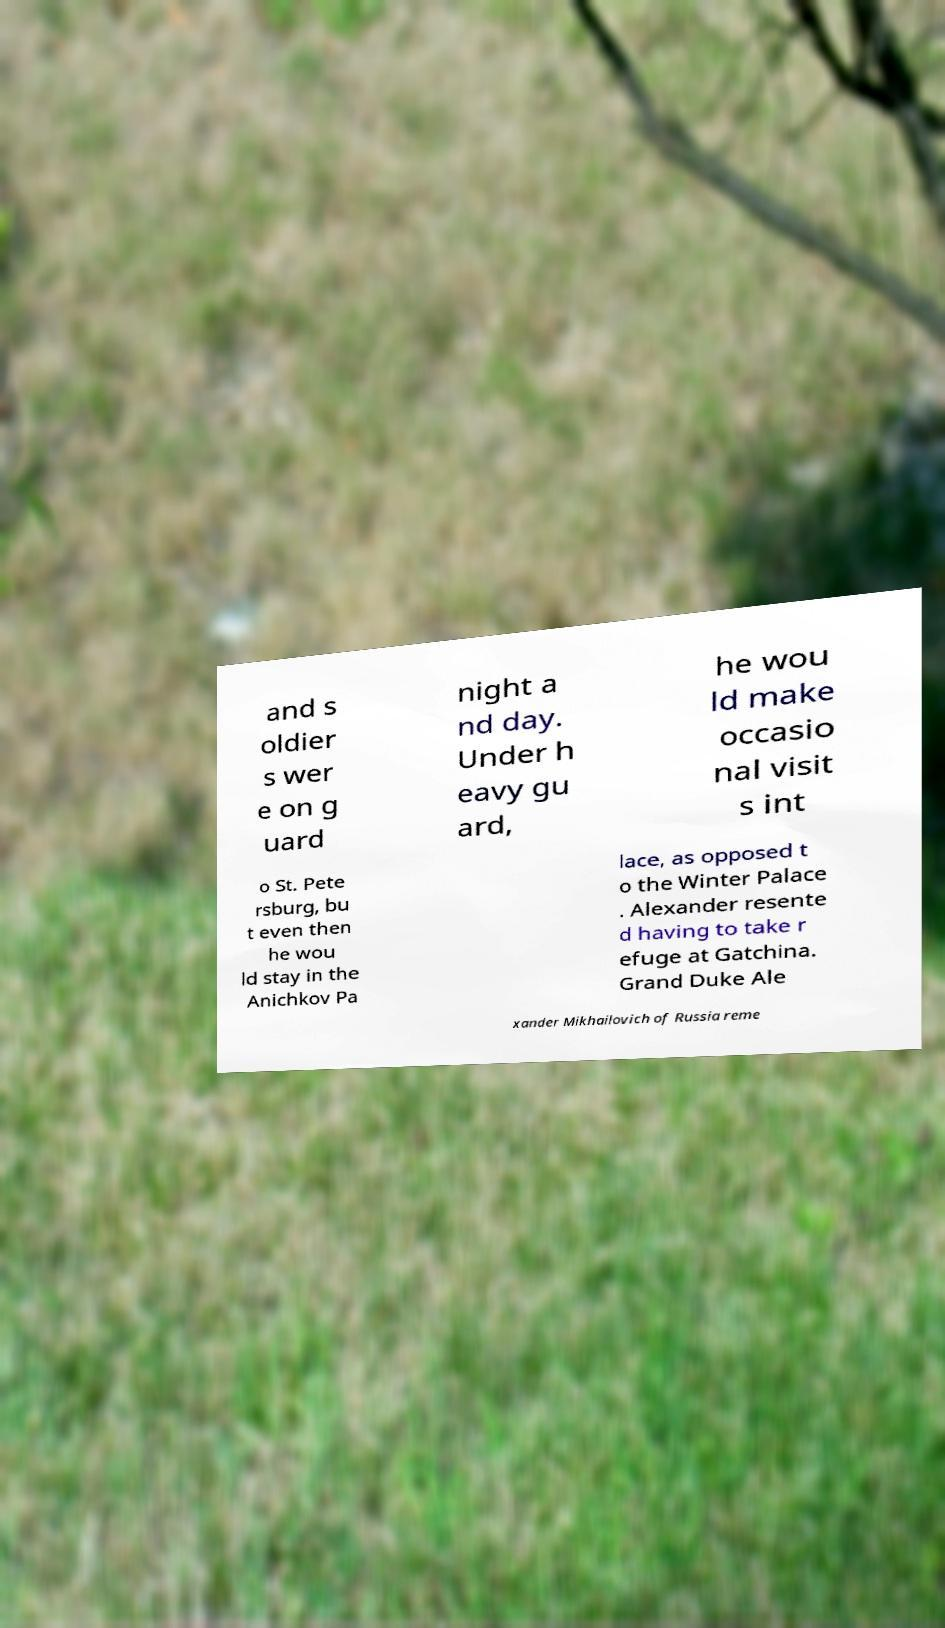Please read and relay the text visible in this image. What does it say? and s oldier s wer e on g uard night a nd day. Under h eavy gu ard, he wou ld make occasio nal visit s int o St. Pete rsburg, bu t even then he wou ld stay in the Anichkov Pa lace, as opposed t o the Winter Palace . Alexander resente d having to take r efuge at Gatchina. Grand Duke Ale xander Mikhailovich of Russia reme 